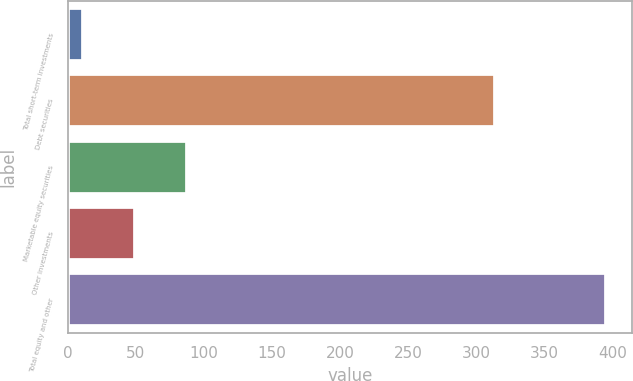Convert chart. <chart><loc_0><loc_0><loc_500><loc_500><bar_chart><fcel>Total short-term investments<fcel>Debt securities<fcel>Marketable equity securities<fcel>Other investments<fcel>Total equity and other<nl><fcel>11<fcel>314<fcel>87.8<fcel>49.4<fcel>395<nl></chart> 